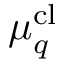<formula> <loc_0><loc_0><loc_500><loc_500>\mu _ { q } ^ { c l }</formula> 